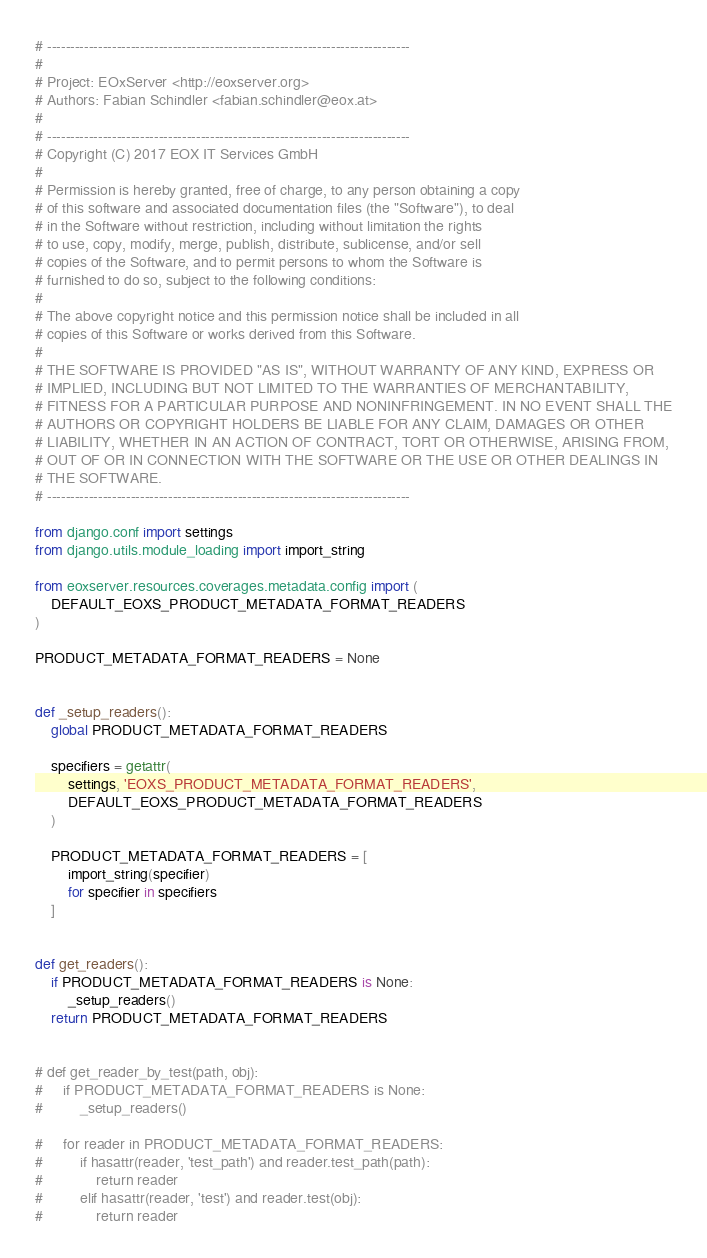Convert code to text. <code><loc_0><loc_0><loc_500><loc_500><_Python_># ------------------------------------------------------------------------------
#
# Project: EOxServer <http://eoxserver.org>
# Authors: Fabian Schindler <fabian.schindler@eox.at>
#
# ------------------------------------------------------------------------------
# Copyright (C) 2017 EOX IT Services GmbH
#
# Permission is hereby granted, free of charge, to any person obtaining a copy
# of this software and associated documentation files (the "Software"), to deal
# in the Software without restriction, including without limitation the rights
# to use, copy, modify, merge, publish, distribute, sublicense, and/or sell
# copies of the Software, and to permit persons to whom the Software is
# furnished to do so, subject to the following conditions:
#
# The above copyright notice and this permission notice shall be included in all
# copies of this Software or works derived from this Software.
#
# THE SOFTWARE IS PROVIDED "AS IS", WITHOUT WARRANTY OF ANY KIND, EXPRESS OR
# IMPLIED, INCLUDING BUT NOT LIMITED TO THE WARRANTIES OF MERCHANTABILITY,
# FITNESS FOR A PARTICULAR PURPOSE AND NONINFRINGEMENT. IN NO EVENT SHALL THE
# AUTHORS OR COPYRIGHT HOLDERS BE LIABLE FOR ANY CLAIM, DAMAGES OR OTHER
# LIABILITY, WHETHER IN AN ACTION OF CONTRACT, TORT OR OTHERWISE, ARISING FROM,
# OUT OF OR IN CONNECTION WITH THE SOFTWARE OR THE USE OR OTHER DEALINGS IN
# THE SOFTWARE.
# ------------------------------------------------------------------------------

from django.conf import settings
from django.utils.module_loading import import_string

from eoxserver.resources.coverages.metadata.config import (
    DEFAULT_EOXS_PRODUCT_METADATA_FORMAT_READERS
)

PRODUCT_METADATA_FORMAT_READERS = None


def _setup_readers():
    global PRODUCT_METADATA_FORMAT_READERS

    specifiers = getattr(
        settings, 'EOXS_PRODUCT_METADATA_FORMAT_READERS',
        DEFAULT_EOXS_PRODUCT_METADATA_FORMAT_READERS
    )

    PRODUCT_METADATA_FORMAT_READERS = [
        import_string(specifier)
        for specifier in specifiers
    ]


def get_readers():
    if PRODUCT_METADATA_FORMAT_READERS is None:
        _setup_readers()
    return PRODUCT_METADATA_FORMAT_READERS


# def get_reader_by_test(path, obj):
#     if PRODUCT_METADATA_FORMAT_READERS is None:
#         _setup_readers()

#     for reader in PRODUCT_METADATA_FORMAT_READERS:
#         if hasattr(reader, 'test_path') and reader.test_path(path):
#             return reader
#         elif hasattr(reader, 'test') and reader.test(obj):
#             return reader
</code> 